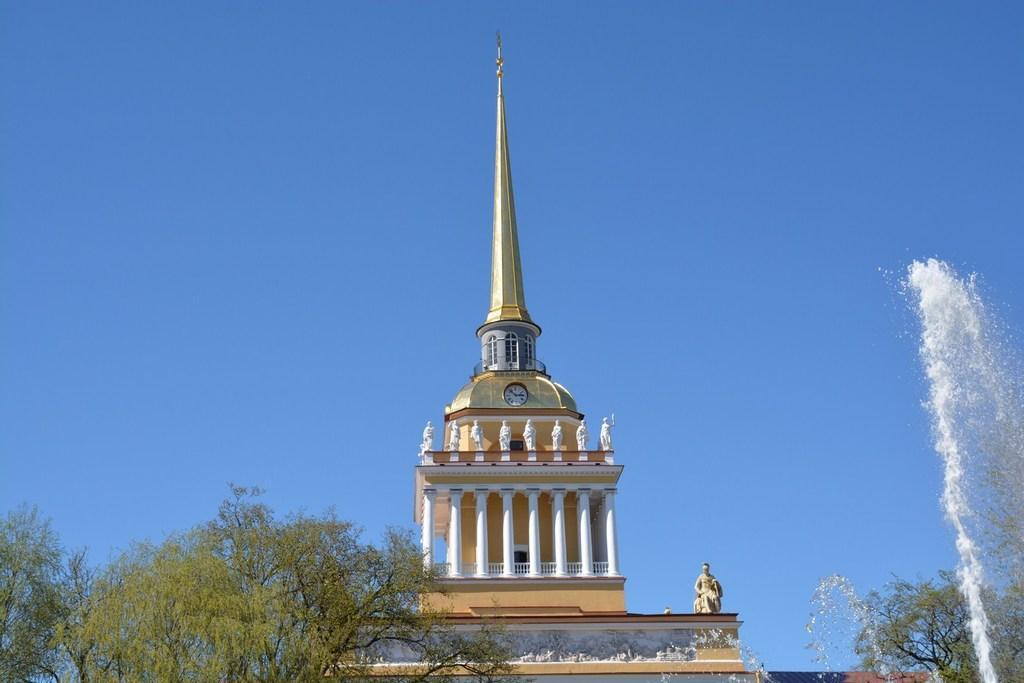How would you summarize this image in a sentence or two? In the foreground of this image, there are trees and water in the air. In the background, there is a building and the sky on the top. 